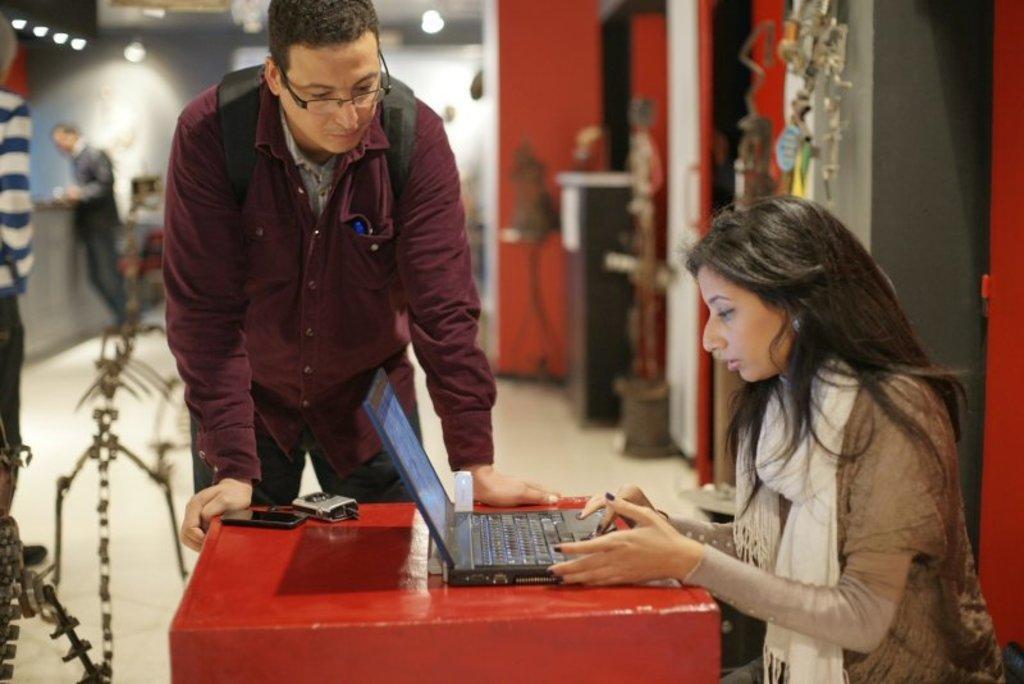How would you summarize this image in a sentence or two? In this image I can see three people with different color dresses. I can see one person is siting in-front of the laptop. The laptop, mobile and some objects are on the red color surface. In the background I can see the lights but it is blurry. 